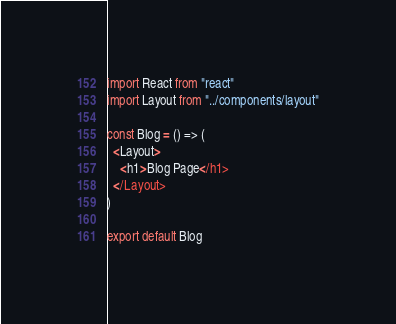Convert code to text. <code><loc_0><loc_0><loc_500><loc_500><_JavaScript_>import React from "react"
import Layout from "../components/layout"

const Blog = () => (
  <Layout>
    <h1>Blog Page</h1>
  </Layout>
)

export default Blog
</code> 